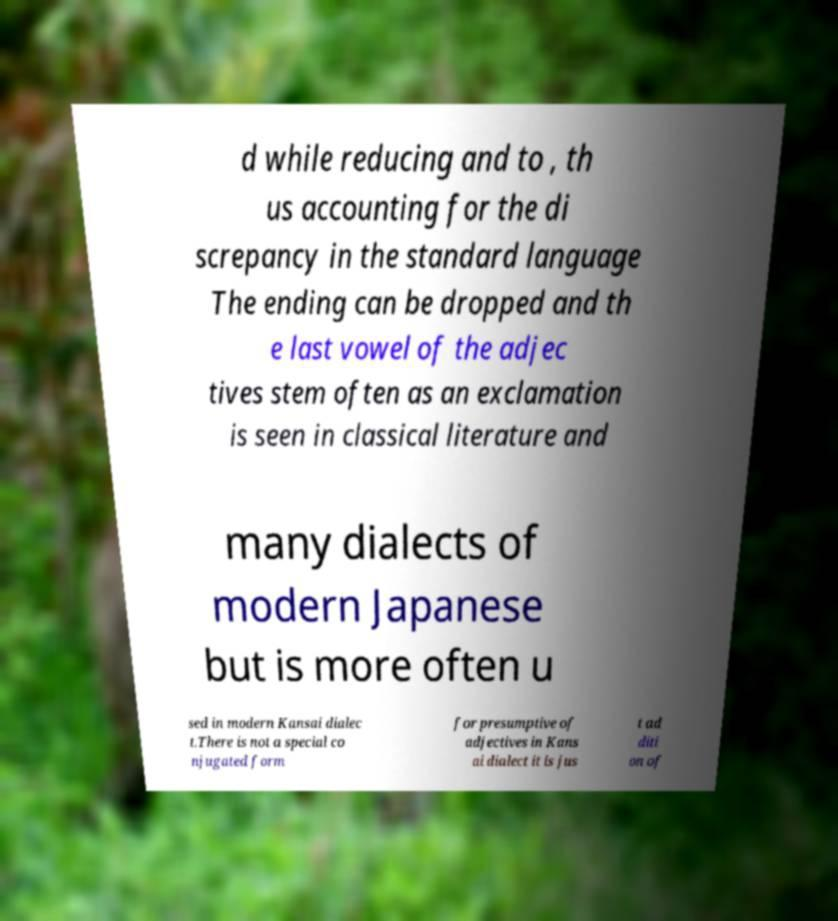What messages or text are displayed in this image? I need them in a readable, typed format. d while reducing and to , th us accounting for the di screpancy in the standard language The ending can be dropped and th e last vowel of the adjec tives stem often as an exclamation is seen in classical literature and many dialects of modern Japanese but is more often u sed in modern Kansai dialec t.There is not a special co njugated form for presumptive of adjectives in Kans ai dialect it is jus t ad diti on of 